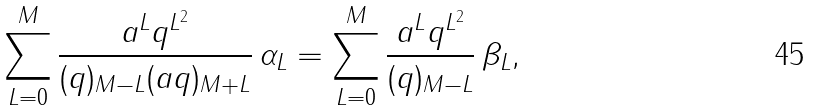Convert formula to latex. <formula><loc_0><loc_0><loc_500><loc_500>\sum _ { L = 0 } ^ { M } \frac { a ^ { L } q ^ { L ^ { 2 } } } { ( q ) _ { M - L } ( a q ) _ { M + L } } \, \alpha _ { L } = \sum _ { L = 0 } ^ { M } \frac { a ^ { L } q ^ { L ^ { 2 } } } { ( q ) _ { M - L } } \, \beta _ { L } ,</formula> 